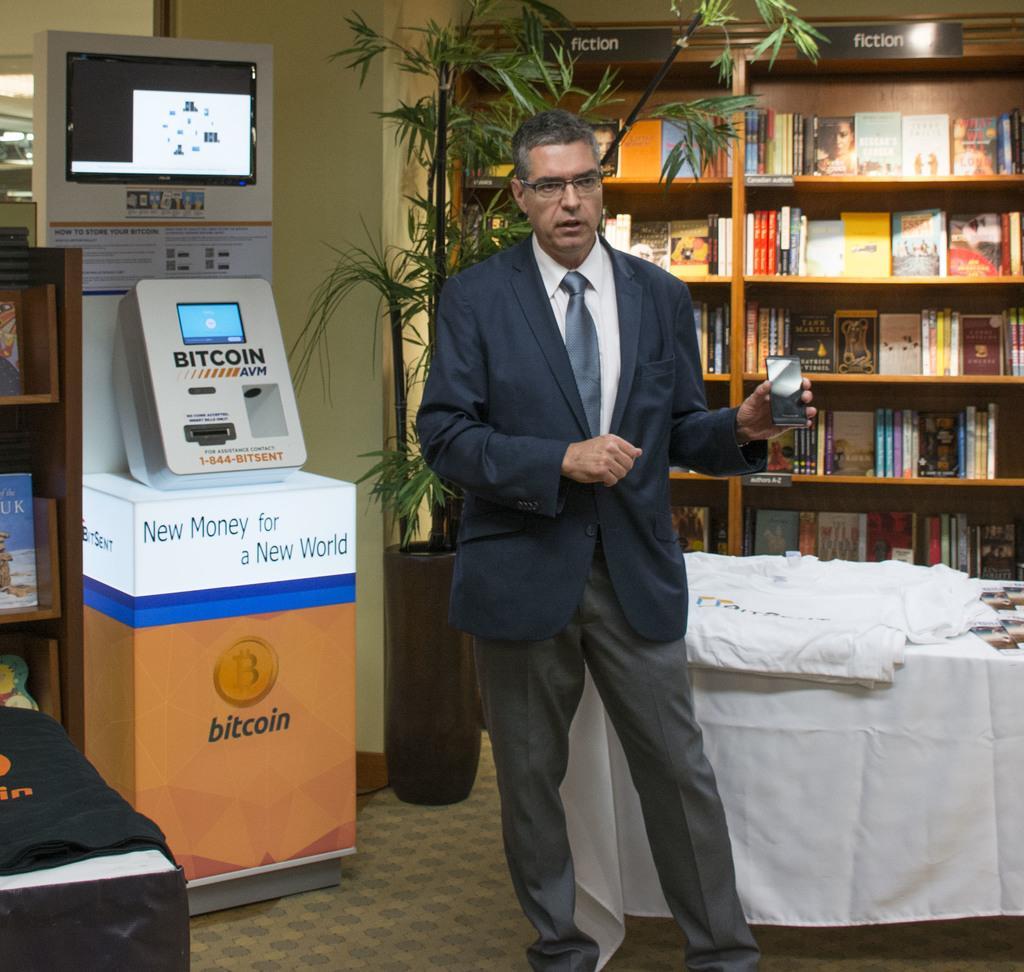Can you describe this image briefly? In the foreground I can see a person is standing on the floor and holding a mobile in hand. In the background I can see a table, cupboard in which books are there, houseplant, PC, machine and a wall. This image is taken in a room. 